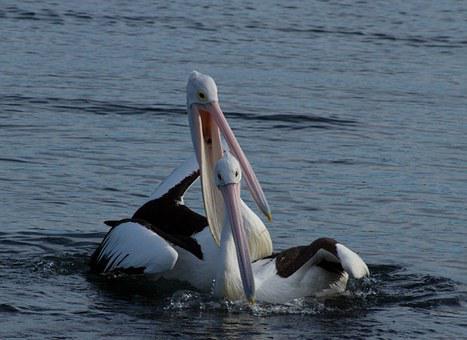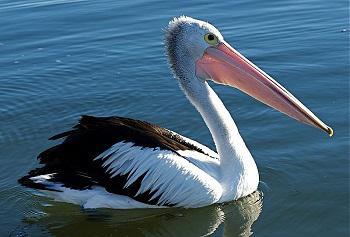The first image is the image on the left, the second image is the image on the right. Given the left and right images, does the statement "There are exactly two birds in one of the images." hold true? Answer yes or no. Yes. 